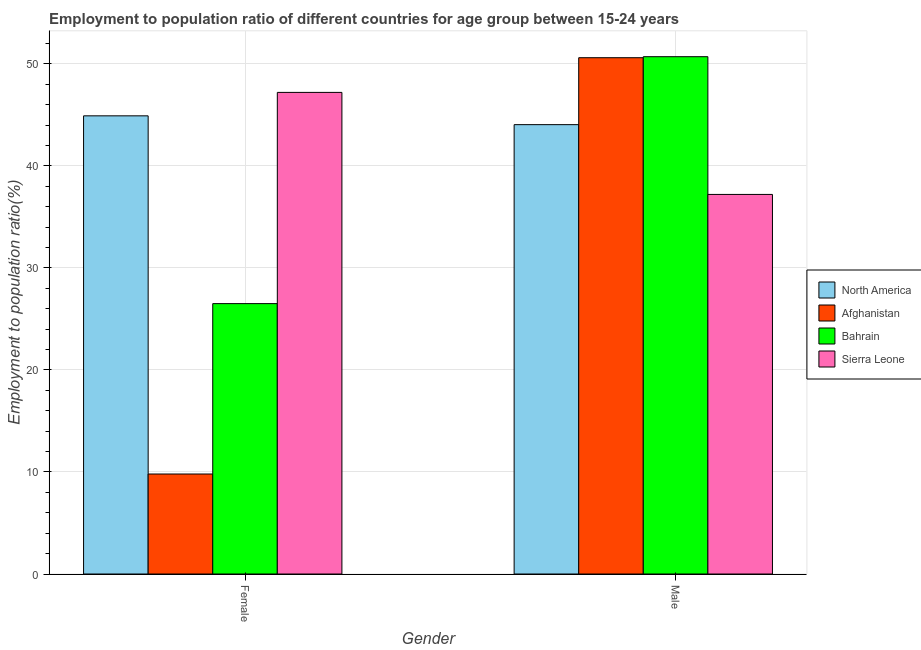What is the label of the 1st group of bars from the left?
Offer a terse response. Female. What is the employment to population ratio(male) in North America?
Your response must be concise. 44.04. Across all countries, what is the maximum employment to population ratio(female)?
Your answer should be compact. 47.2. Across all countries, what is the minimum employment to population ratio(male)?
Your response must be concise. 37.2. In which country was the employment to population ratio(male) maximum?
Ensure brevity in your answer.  Bahrain. In which country was the employment to population ratio(male) minimum?
Provide a short and direct response. Sierra Leone. What is the total employment to population ratio(male) in the graph?
Make the answer very short. 182.54. What is the difference between the employment to population ratio(female) in Bahrain and that in Sierra Leone?
Provide a short and direct response. -20.7. What is the difference between the employment to population ratio(male) in Sierra Leone and the employment to population ratio(female) in North America?
Your answer should be compact. -7.7. What is the average employment to population ratio(male) per country?
Your response must be concise. 45.63. What is the difference between the employment to population ratio(female) and employment to population ratio(male) in North America?
Your response must be concise. 0.86. In how many countries, is the employment to population ratio(male) greater than 48 %?
Your response must be concise. 2. What is the ratio of the employment to population ratio(female) in North America to that in Bahrain?
Offer a very short reply. 1.69. Is the employment to population ratio(female) in North America less than that in Bahrain?
Your answer should be compact. No. In how many countries, is the employment to population ratio(female) greater than the average employment to population ratio(female) taken over all countries?
Make the answer very short. 2. What does the 2nd bar from the left in Male represents?
Ensure brevity in your answer.  Afghanistan. What does the 4th bar from the right in Male represents?
Your response must be concise. North America. Are all the bars in the graph horizontal?
Offer a terse response. No. Are the values on the major ticks of Y-axis written in scientific E-notation?
Make the answer very short. No. Does the graph contain any zero values?
Your response must be concise. No. Does the graph contain grids?
Offer a very short reply. Yes. How many legend labels are there?
Keep it short and to the point. 4. How are the legend labels stacked?
Give a very brief answer. Vertical. What is the title of the graph?
Offer a very short reply. Employment to population ratio of different countries for age group between 15-24 years. Does "European Union" appear as one of the legend labels in the graph?
Provide a short and direct response. No. What is the label or title of the X-axis?
Give a very brief answer. Gender. What is the Employment to population ratio(%) in North America in Female?
Your response must be concise. 44.9. What is the Employment to population ratio(%) of Afghanistan in Female?
Make the answer very short. 9.8. What is the Employment to population ratio(%) of Bahrain in Female?
Provide a succinct answer. 26.5. What is the Employment to population ratio(%) of Sierra Leone in Female?
Your response must be concise. 47.2. What is the Employment to population ratio(%) of North America in Male?
Your answer should be compact. 44.04. What is the Employment to population ratio(%) in Afghanistan in Male?
Give a very brief answer. 50.6. What is the Employment to population ratio(%) in Bahrain in Male?
Offer a very short reply. 50.7. What is the Employment to population ratio(%) of Sierra Leone in Male?
Keep it short and to the point. 37.2. Across all Gender, what is the maximum Employment to population ratio(%) of North America?
Your answer should be compact. 44.9. Across all Gender, what is the maximum Employment to population ratio(%) of Afghanistan?
Ensure brevity in your answer.  50.6. Across all Gender, what is the maximum Employment to population ratio(%) in Bahrain?
Your answer should be compact. 50.7. Across all Gender, what is the maximum Employment to population ratio(%) in Sierra Leone?
Provide a succinct answer. 47.2. Across all Gender, what is the minimum Employment to population ratio(%) in North America?
Offer a terse response. 44.04. Across all Gender, what is the minimum Employment to population ratio(%) of Afghanistan?
Ensure brevity in your answer.  9.8. Across all Gender, what is the minimum Employment to population ratio(%) in Bahrain?
Give a very brief answer. 26.5. Across all Gender, what is the minimum Employment to population ratio(%) of Sierra Leone?
Give a very brief answer. 37.2. What is the total Employment to population ratio(%) in North America in the graph?
Make the answer very short. 88.94. What is the total Employment to population ratio(%) of Afghanistan in the graph?
Keep it short and to the point. 60.4. What is the total Employment to population ratio(%) of Bahrain in the graph?
Provide a succinct answer. 77.2. What is the total Employment to population ratio(%) of Sierra Leone in the graph?
Make the answer very short. 84.4. What is the difference between the Employment to population ratio(%) in North America in Female and that in Male?
Offer a terse response. 0.86. What is the difference between the Employment to population ratio(%) of Afghanistan in Female and that in Male?
Provide a succinct answer. -40.8. What is the difference between the Employment to population ratio(%) in Bahrain in Female and that in Male?
Your response must be concise. -24.2. What is the difference between the Employment to population ratio(%) of Sierra Leone in Female and that in Male?
Offer a terse response. 10. What is the difference between the Employment to population ratio(%) of North America in Female and the Employment to population ratio(%) of Afghanistan in Male?
Keep it short and to the point. -5.7. What is the difference between the Employment to population ratio(%) in North America in Female and the Employment to population ratio(%) in Bahrain in Male?
Offer a very short reply. -5.8. What is the difference between the Employment to population ratio(%) of North America in Female and the Employment to population ratio(%) of Sierra Leone in Male?
Offer a very short reply. 7.7. What is the difference between the Employment to population ratio(%) of Afghanistan in Female and the Employment to population ratio(%) of Bahrain in Male?
Your answer should be very brief. -40.9. What is the difference between the Employment to population ratio(%) in Afghanistan in Female and the Employment to population ratio(%) in Sierra Leone in Male?
Ensure brevity in your answer.  -27.4. What is the difference between the Employment to population ratio(%) of Bahrain in Female and the Employment to population ratio(%) of Sierra Leone in Male?
Provide a short and direct response. -10.7. What is the average Employment to population ratio(%) of North America per Gender?
Make the answer very short. 44.47. What is the average Employment to population ratio(%) in Afghanistan per Gender?
Keep it short and to the point. 30.2. What is the average Employment to population ratio(%) of Bahrain per Gender?
Keep it short and to the point. 38.6. What is the average Employment to population ratio(%) of Sierra Leone per Gender?
Offer a terse response. 42.2. What is the difference between the Employment to population ratio(%) of North America and Employment to population ratio(%) of Afghanistan in Female?
Your response must be concise. 35.1. What is the difference between the Employment to population ratio(%) of North America and Employment to population ratio(%) of Bahrain in Female?
Give a very brief answer. 18.4. What is the difference between the Employment to population ratio(%) of North America and Employment to population ratio(%) of Sierra Leone in Female?
Your response must be concise. -2.3. What is the difference between the Employment to population ratio(%) of Afghanistan and Employment to population ratio(%) of Bahrain in Female?
Provide a succinct answer. -16.7. What is the difference between the Employment to population ratio(%) of Afghanistan and Employment to population ratio(%) of Sierra Leone in Female?
Offer a very short reply. -37.4. What is the difference between the Employment to population ratio(%) in Bahrain and Employment to population ratio(%) in Sierra Leone in Female?
Offer a terse response. -20.7. What is the difference between the Employment to population ratio(%) in North America and Employment to population ratio(%) in Afghanistan in Male?
Provide a short and direct response. -6.56. What is the difference between the Employment to population ratio(%) of North America and Employment to population ratio(%) of Bahrain in Male?
Your response must be concise. -6.66. What is the difference between the Employment to population ratio(%) in North America and Employment to population ratio(%) in Sierra Leone in Male?
Make the answer very short. 6.84. What is the difference between the Employment to population ratio(%) of Afghanistan and Employment to population ratio(%) of Bahrain in Male?
Give a very brief answer. -0.1. What is the difference between the Employment to population ratio(%) of Bahrain and Employment to population ratio(%) of Sierra Leone in Male?
Offer a very short reply. 13.5. What is the ratio of the Employment to population ratio(%) in North America in Female to that in Male?
Your answer should be compact. 1.02. What is the ratio of the Employment to population ratio(%) of Afghanistan in Female to that in Male?
Your response must be concise. 0.19. What is the ratio of the Employment to population ratio(%) in Bahrain in Female to that in Male?
Give a very brief answer. 0.52. What is the ratio of the Employment to population ratio(%) in Sierra Leone in Female to that in Male?
Keep it short and to the point. 1.27. What is the difference between the highest and the second highest Employment to population ratio(%) of North America?
Ensure brevity in your answer.  0.86. What is the difference between the highest and the second highest Employment to population ratio(%) in Afghanistan?
Your response must be concise. 40.8. What is the difference between the highest and the second highest Employment to population ratio(%) in Bahrain?
Give a very brief answer. 24.2. What is the difference between the highest and the second highest Employment to population ratio(%) of Sierra Leone?
Ensure brevity in your answer.  10. What is the difference between the highest and the lowest Employment to population ratio(%) in North America?
Make the answer very short. 0.86. What is the difference between the highest and the lowest Employment to population ratio(%) in Afghanistan?
Your answer should be compact. 40.8. What is the difference between the highest and the lowest Employment to population ratio(%) in Bahrain?
Your answer should be very brief. 24.2. 